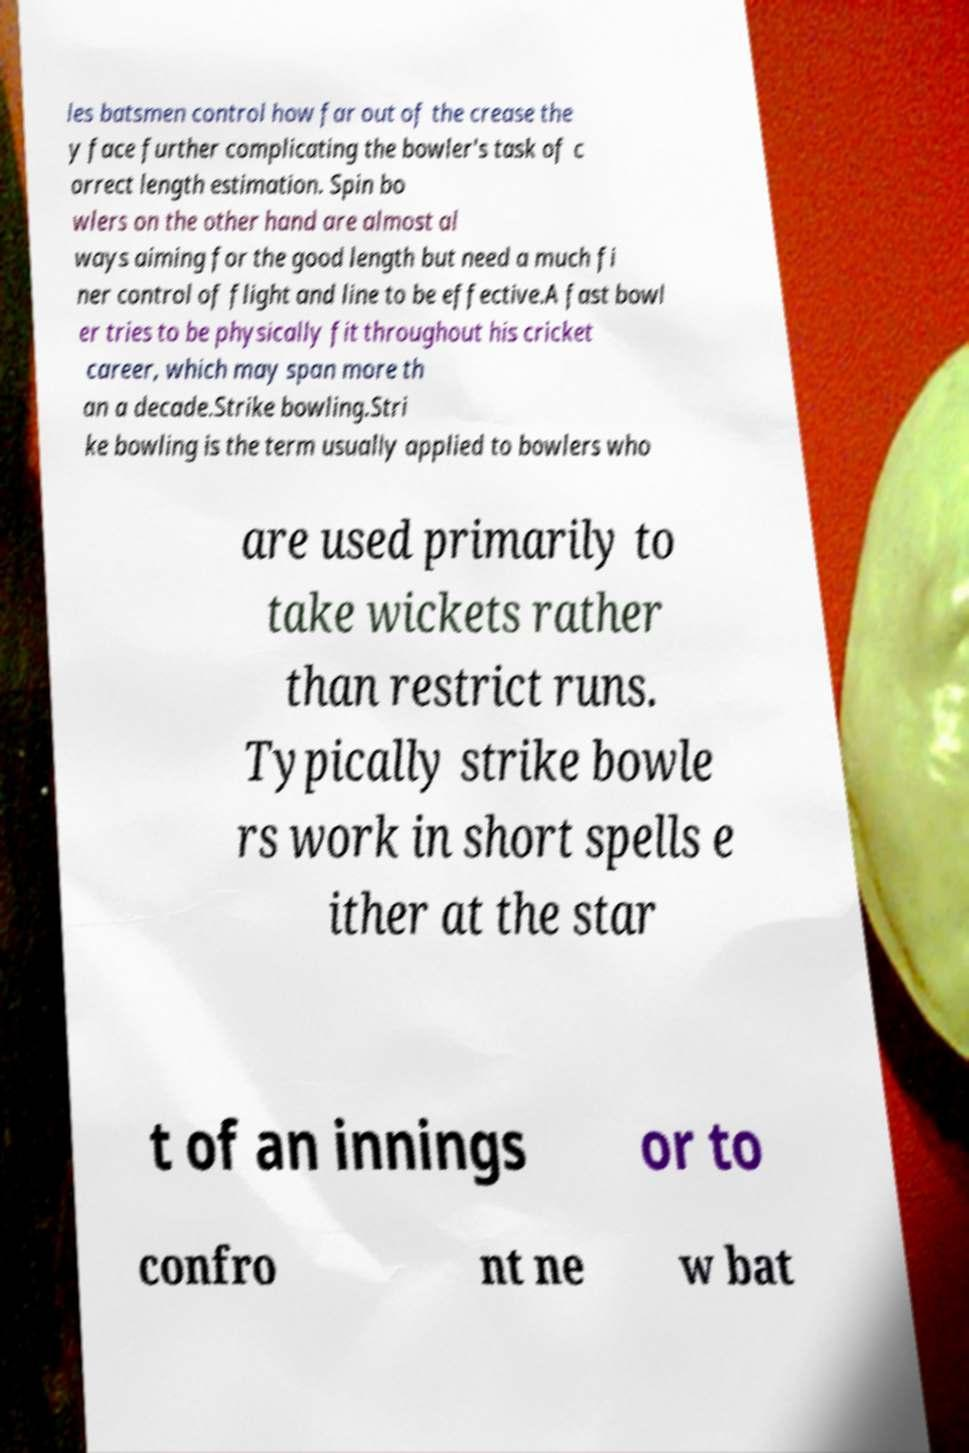For documentation purposes, I need the text within this image transcribed. Could you provide that? les batsmen control how far out of the crease the y face further complicating the bowler's task of c orrect length estimation. Spin bo wlers on the other hand are almost al ways aiming for the good length but need a much fi ner control of flight and line to be effective.A fast bowl er tries to be physically fit throughout his cricket career, which may span more th an a decade.Strike bowling.Stri ke bowling is the term usually applied to bowlers who are used primarily to take wickets rather than restrict runs. Typically strike bowle rs work in short spells e ither at the star t of an innings or to confro nt ne w bat 